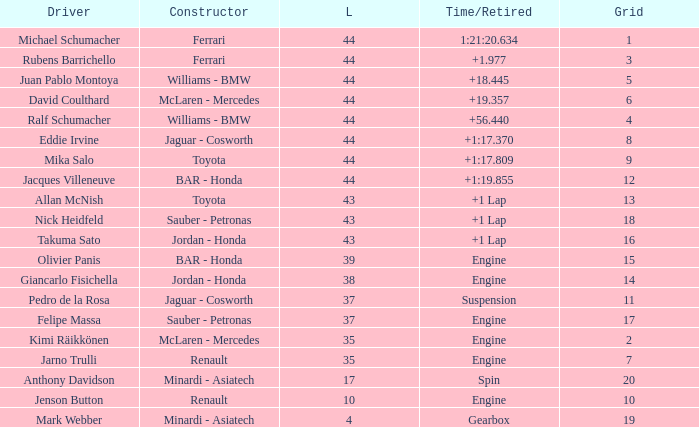What was the retired time on someone who had 43 laps on a grip of 18? +1 Lap. 